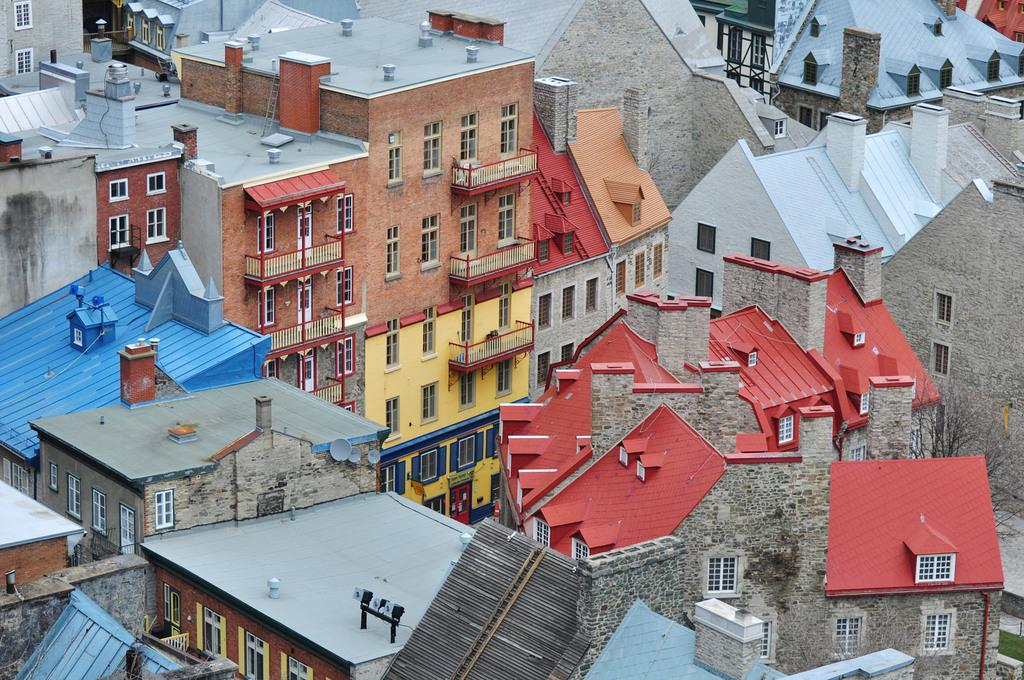What type of structures are present in the image? There are buildings in the image. How can the buildings be distinguished from one another? The buildings are in different colors. What architectural features are visible on the buildings? There are windows and balconies visible on the buildings. Can you see a crook leaning against the building in the image? There is no crook present in the image. Are there any skateboards visible on the balconies of the buildings? There are no skateboards visible on the balconies of the buildings. 